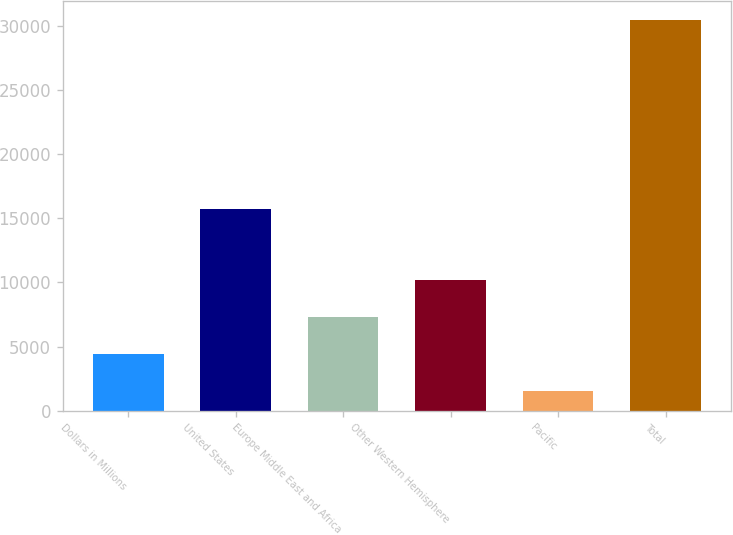Convert chart to OTSL. <chart><loc_0><loc_0><loc_500><loc_500><bar_chart><fcel>Dollars in Millions<fcel>United States<fcel>Europe Middle East and Africa<fcel>Other Western Hemisphere<fcel>Pacific<fcel>Total<nl><fcel>4447.5<fcel>15727<fcel>7335<fcel>10222.5<fcel>1560<fcel>30435<nl></chart> 